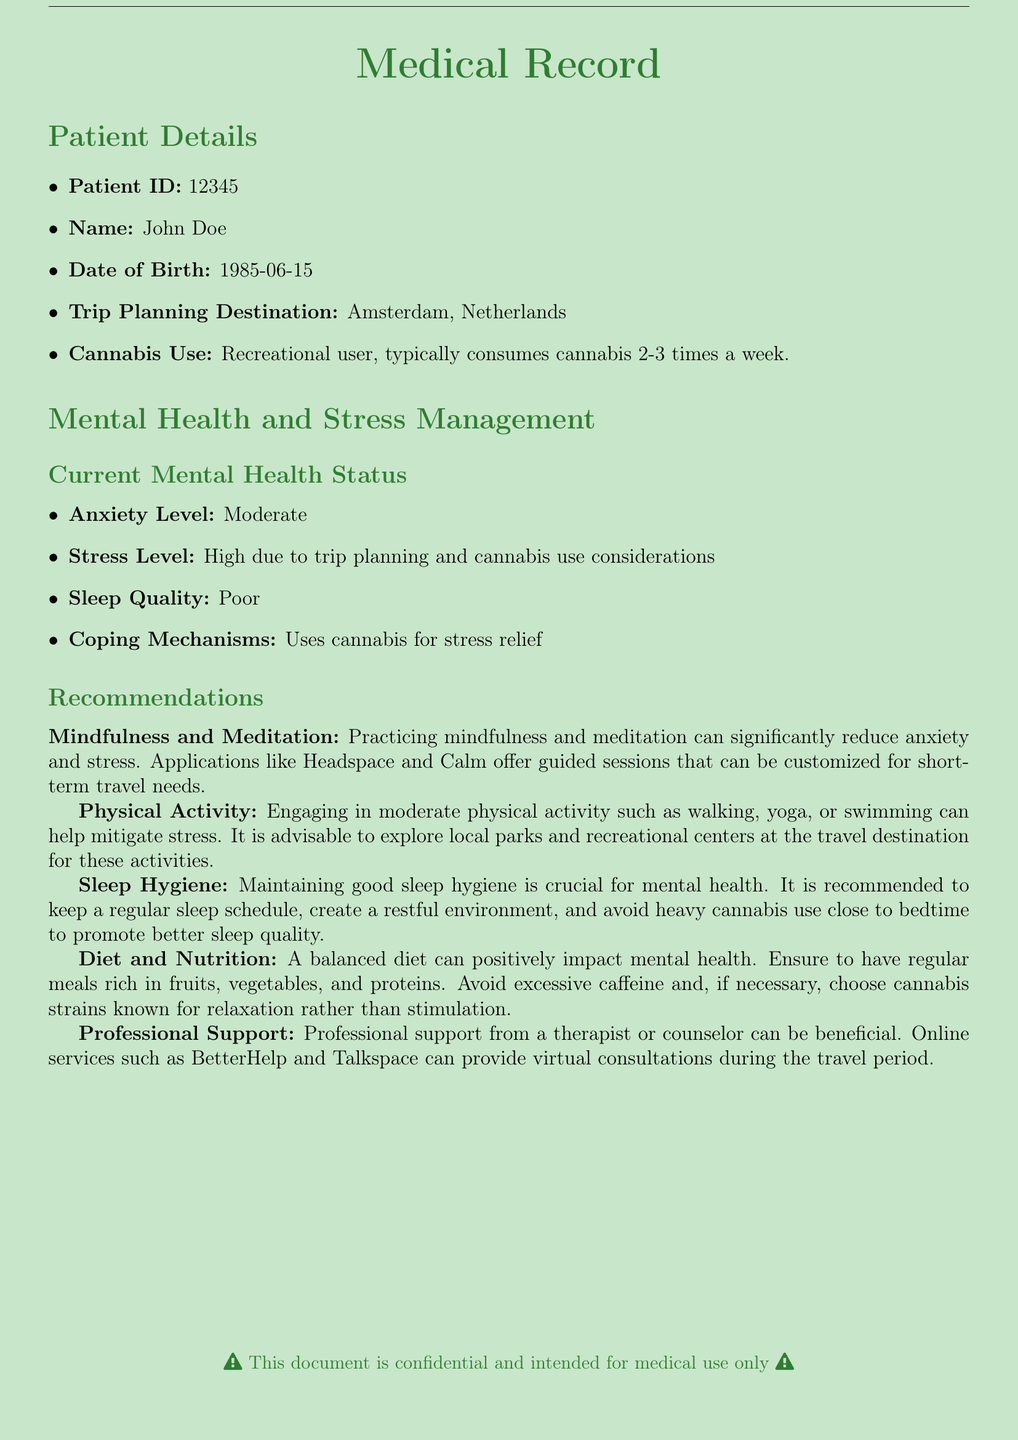What is the Patient ID? The Patient ID is listed at the beginning of the Patient Details section of the document.
Answer: 12345 What is the date of birth of the patient? The date of birth is mentioned in the Patient Details section.
Answer: 1985-06-15 What is the stress level reported by the patient? The stress level is specified in the Current Mental Health Status section.
Answer: High What coping mechanism does the patient use for stress relief? The coping mechanism is mentioned under Current Mental Health Status.
Answer: Uses cannabis for stress relief Which app is recommended for mindfulness and meditation? The recommendations section lists applications suitable for mindfulness.
Answer: Headspace and Calm What type of physical activity is suggested for stress management? The recommendations section mentions physical activities beneficial for stress management.
Answer: Moderate physical activity What is advised to maintain good sleep hygiene? Sleep hygiene tips are provided in the recommendations section of the document.
Answer: Create a restful environment Which online services can provide professional support during travel? The document specifies online services for professional support.
Answer: BetterHelp and Talkspace What is the anxiety level of the patient? This information is provided in the Current Mental Health Status.
Answer: Moderate 